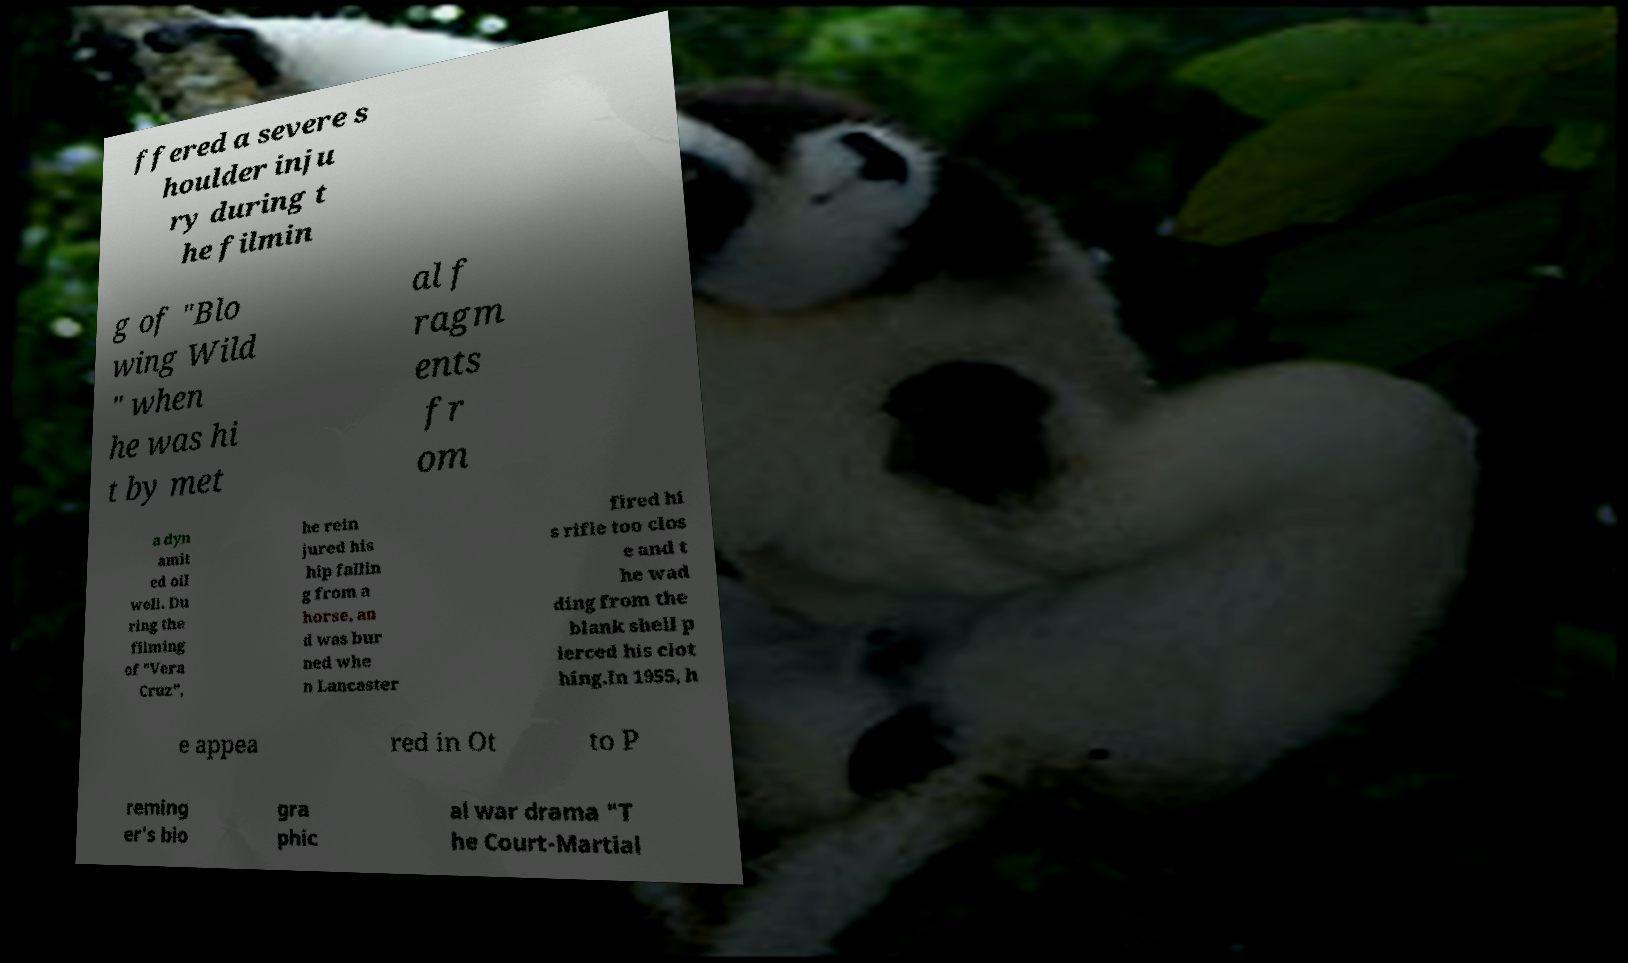I need the written content from this picture converted into text. Can you do that? ffered a severe s houlder inju ry during t he filmin g of "Blo wing Wild " when he was hi t by met al f ragm ents fr om a dyn amit ed oil well. Du ring the filming of "Vera Cruz", he rein jured his hip fallin g from a horse, an d was bur ned whe n Lancaster fired hi s rifle too clos e and t he wad ding from the blank shell p ierced his clot hing.In 1955, h e appea red in Ot to P reming er's bio gra phic al war drama "T he Court-Martial 